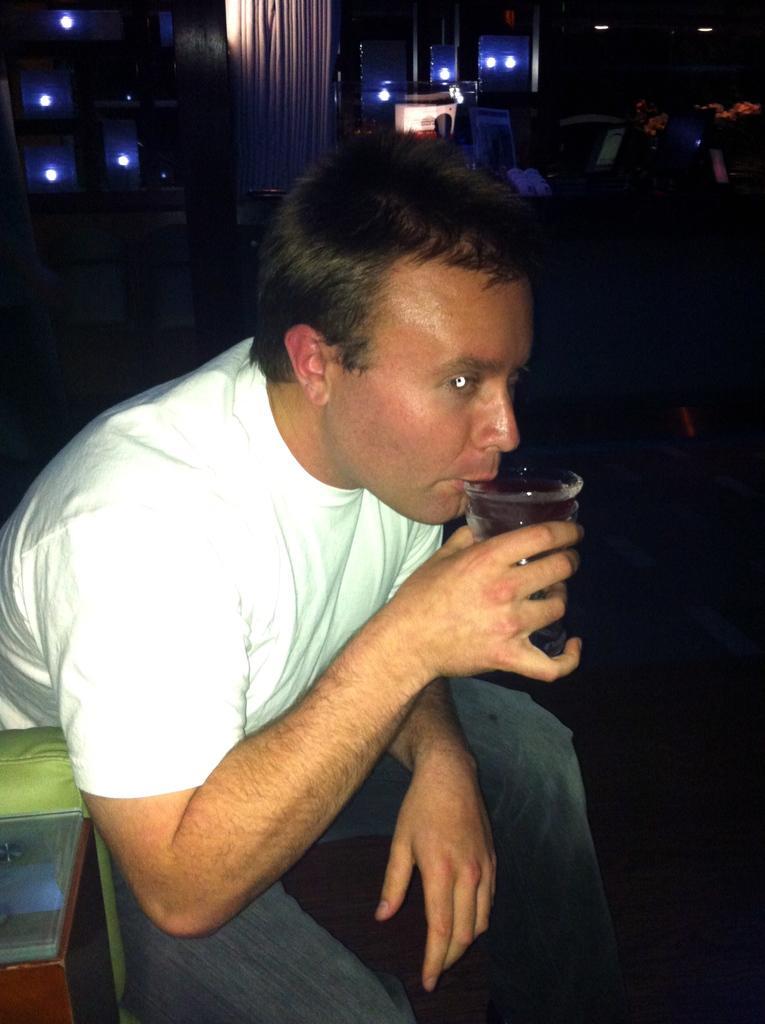Could you give a brief overview of what you see in this image? In this picture we can see a person drinking liquid from a glass. We can see an object on the left side. There are a few lights and some objects are visible in the background. 